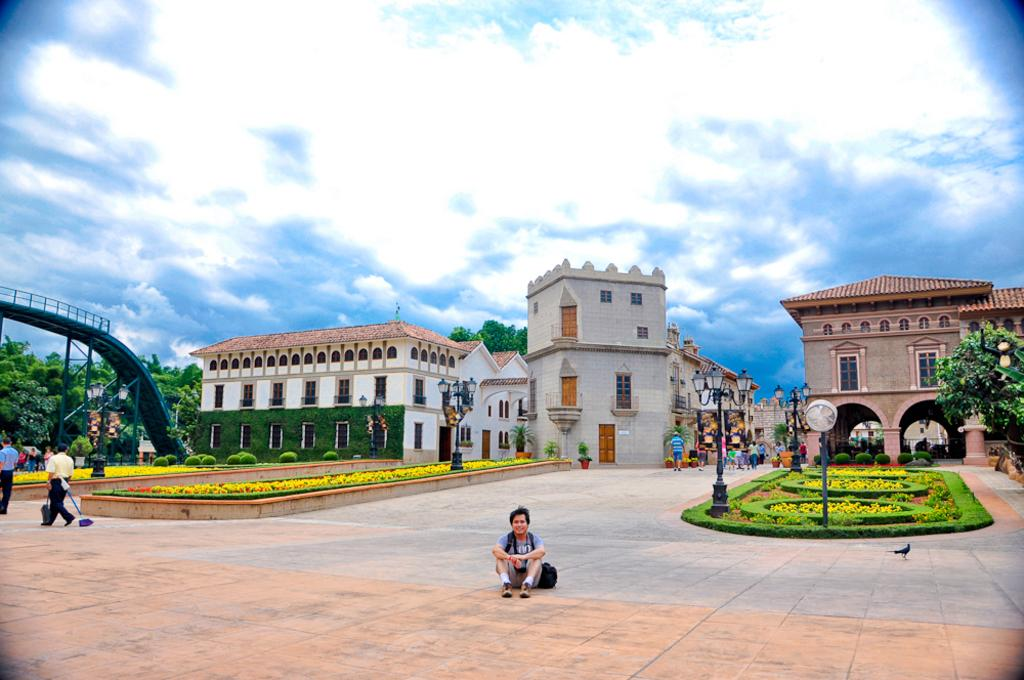How many people are in the image? There are few persons in the image. What type of vegetation can be seen in the image? There are plants, grass, and trees in the image. What structures are present in the image? There are poles, lights, and buildings in the image. What is visible in the background of the image? The sky is visible in the background of the image, with clouds present. How many horses are present in the image? There are no horses visible in the image. What is the name of the daughter in the image? There is no mention of a daughter or any individuals with names in the image. 